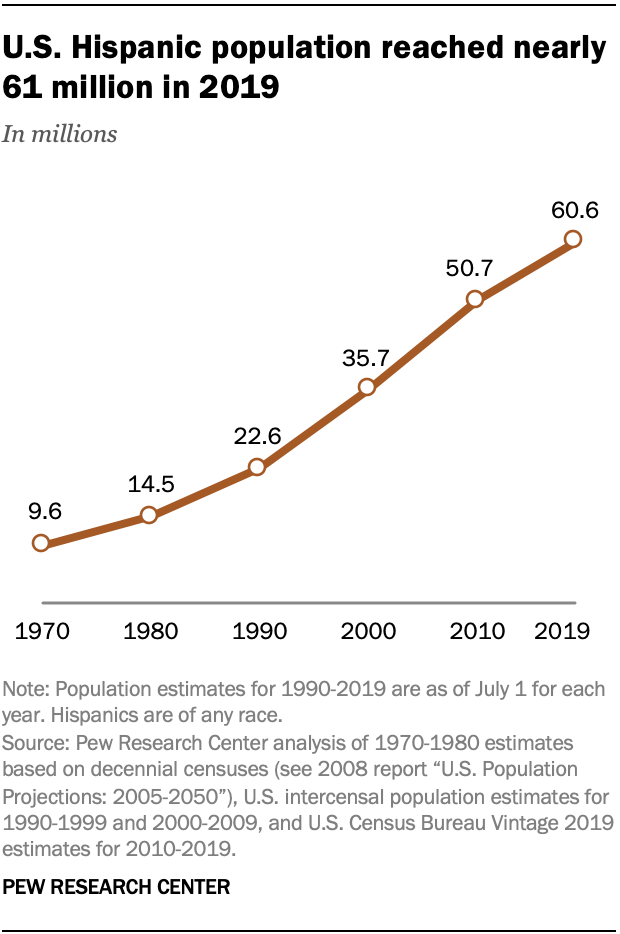Specify some key components in this picture. The highest value the brown segment represents is 60.6. The value in 1980 is not greater than 2010. 